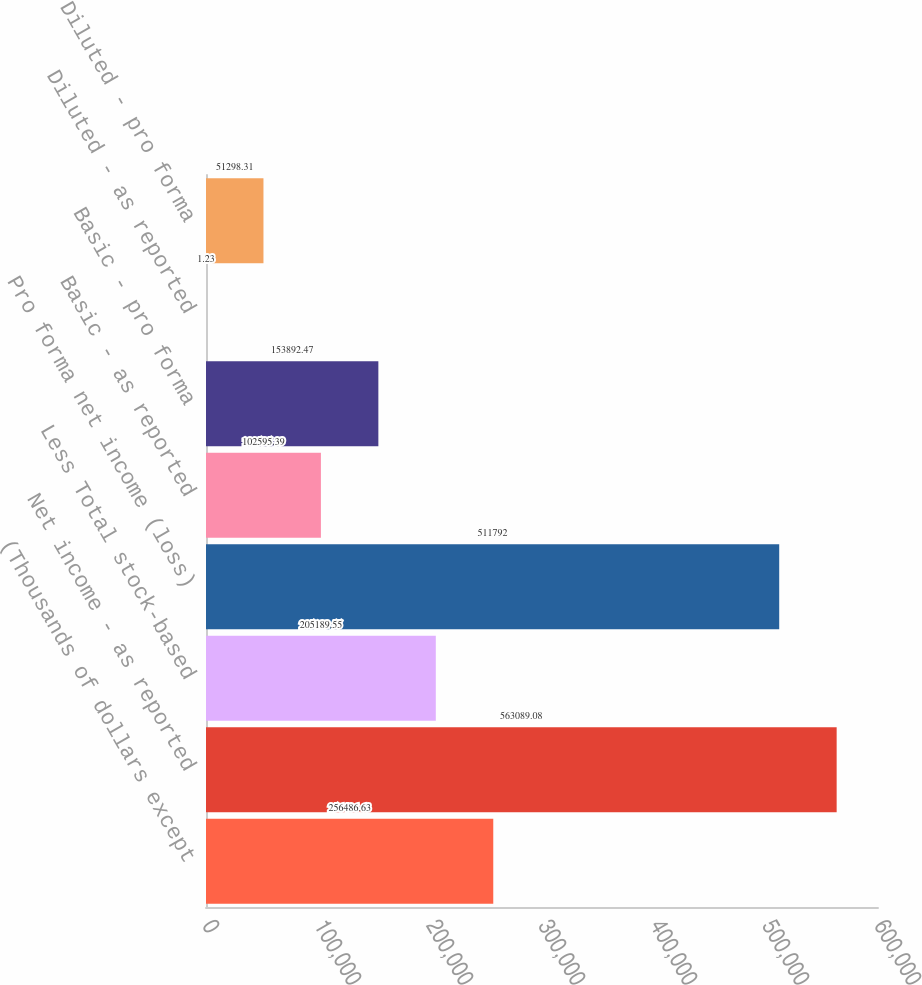Convert chart to OTSL. <chart><loc_0><loc_0><loc_500><loc_500><bar_chart><fcel>(Thousands of dollars except<fcel>Net income - as reported<fcel>Less Total stock-based<fcel>Pro forma net income (loss)<fcel>Basic - as reported<fcel>Basic - pro forma<fcel>Diluted - as reported<fcel>Diluted - pro forma<nl><fcel>256487<fcel>563089<fcel>205190<fcel>511792<fcel>102595<fcel>153892<fcel>1.23<fcel>51298.3<nl></chart> 